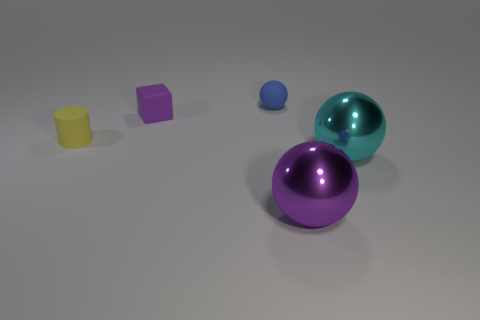Add 4 tiny purple metal cylinders. How many objects exist? 9 Subtract all blocks. How many objects are left? 4 Add 4 cyan metallic balls. How many cyan metallic balls are left? 5 Add 3 tiny brown objects. How many tiny brown objects exist? 3 Subtract 0 gray cylinders. How many objects are left? 5 Subtract all large yellow things. Subtract all rubber balls. How many objects are left? 4 